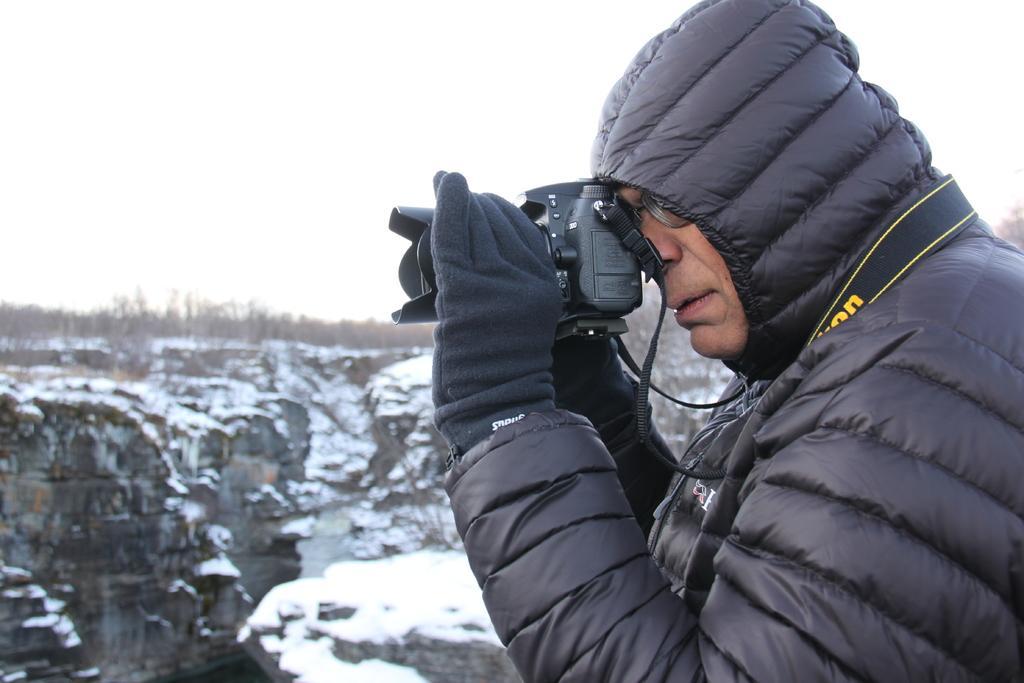Please provide a concise description of this image. In this image I can see a person wearing a black color jacket and taking picture with camera in the background I can see the sky and the hill. 